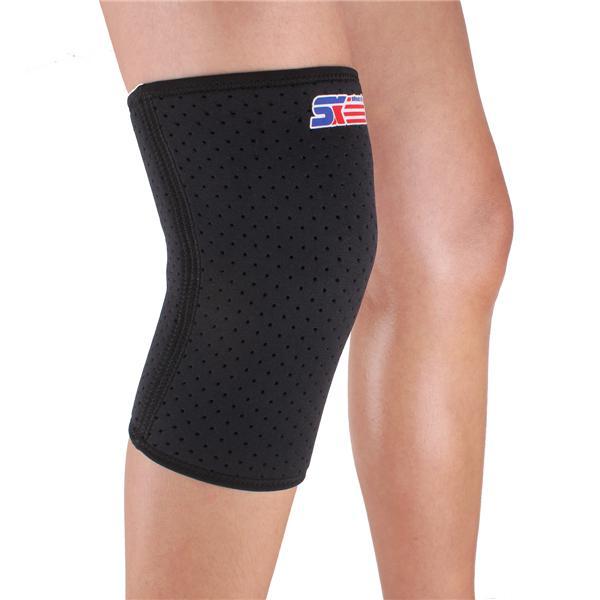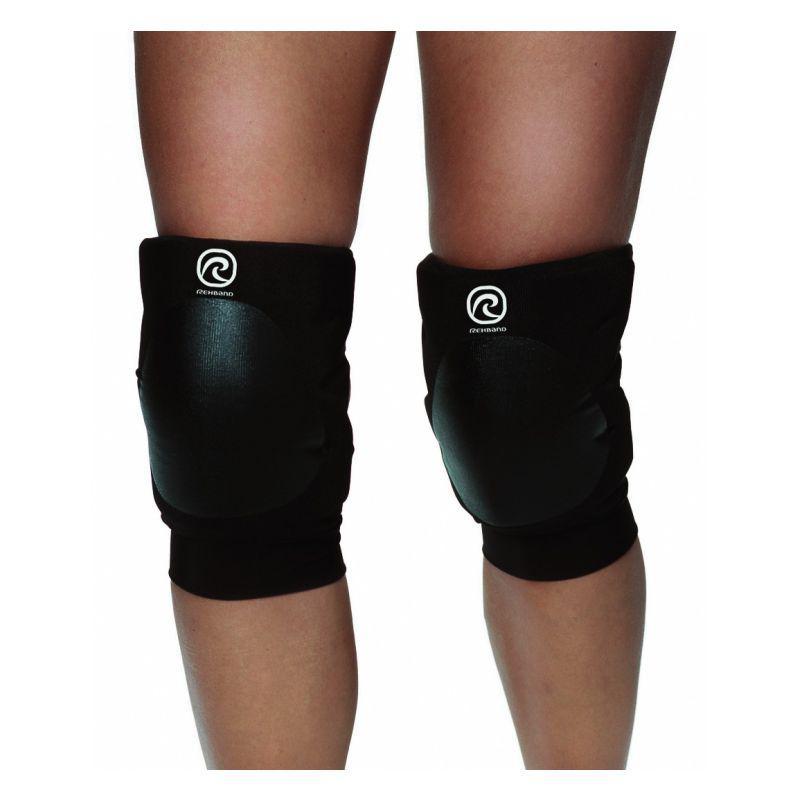The first image is the image on the left, the second image is the image on the right. For the images shown, is this caption "Each image shows one pair of legs wearing a pair of knee pads." true? Answer yes or no. No. The first image is the image on the left, the second image is the image on the right. Analyze the images presented: Is the assertion "There are four legs and four knee pads." valid? Answer yes or no. No. 